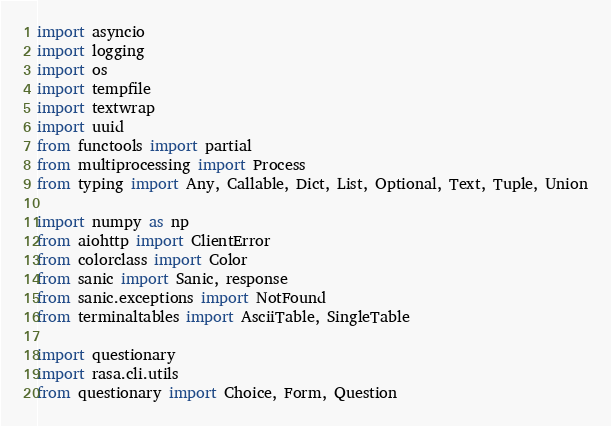Convert code to text. <code><loc_0><loc_0><loc_500><loc_500><_Python_>import asyncio
import logging
import os
import tempfile
import textwrap
import uuid
from functools import partial
from multiprocessing import Process
from typing import Any, Callable, Dict, List, Optional, Text, Tuple, Union

import numpy as np
from aiohttp import ClientError
from colorclass import Color
from sanic import Sanic, response
from sanic.exceptions import NotFound
from terminaltables import AsciiTable, SingleTable

import questionary
import rasa.cli.utils
from questionary import Choice, Form, Question
</code> 